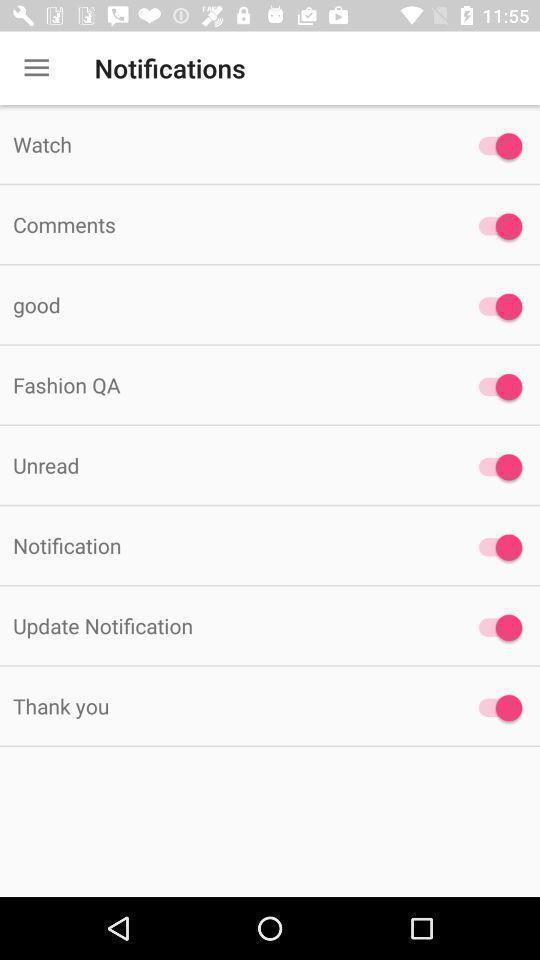Describe the content in this image. Page displays list of notifications in app. 